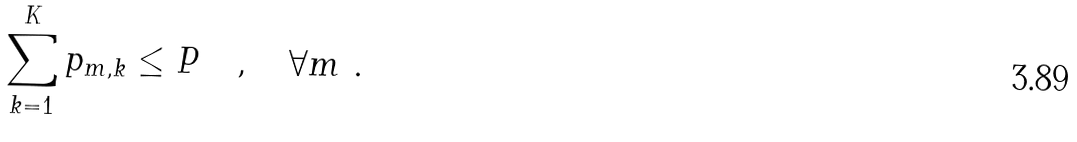<formula> <loc_0><loc_0><loc_500><loc_500>\sum _ { k = 1 } ^ { K } p _ { m , k } \leq P \quad , \quad \forall m \ .</formula> 